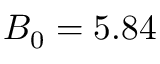<formula> <loc_0><loc_0><loc_500><loc_500>B _ { 0 } = 5 . 8 4</formula> 